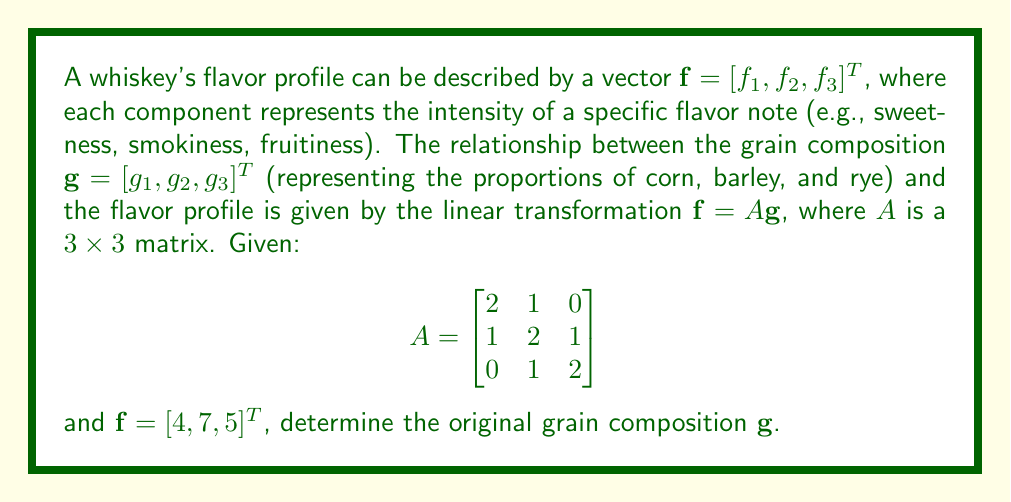Provide a solution to this math problem. To solve this inverse problem and determine the original grain composition, we need to find $\mathbf{g}$ given $\mathbf{f}$ and $A$. This involves solving the linear system $A\mathbf{g} = \mathbf{f}$.

Step 1: Set up the equation $A\mathbf{g} = \mathbf{f}$:
$$\begin{bmatrix}
2 & 1 & 0 \\
1 & 2 & 1 \\
0 & 1 & 2
\end{bmatrix} \begin{bmatrix}
g_1 \\
g_2 \\
g_3
\end{bmatrix} = \begin{bmatrix}
4 \\
7 \\
5
\end{bmatrix}$$

Step 2: To solve this system, we can use Gaussian elimination or matrix inversion. Let's use matrix inversion. We need to find $A^{-1}$.

Step 3: Calculate $A^{-1}$:
$$A^{-1} = \frac{1}{7}\begin{bmatrix}
3 & -1 & 0 \\
-1 & 3 & -1 \\
1 & -1 & 3
\end{bmatrix}$$

Step 4: Multiply both sides of the equation by $A^{-1}$:
$$\mathbf{g} = A^{-1}\mathbf{f}$$

Step 5: Perform the matrix multiplication:
$$\mathbf{g} = \frac{1}{7}\begin{bmatrix}
3 & -1 & 0 \\
-1 & 3 & -1 \\
1 & -1 & 3
\end{bmatrix} \begin{bmatrix}
4 \\
7 \\
5
\end{bmatrix}$$

Step 6: Calculate the result:
$$\mathbf{g} = \frac{1}{7}\begin{bmatrix}
3(4) + (-1)(7) + 0(5) \\
(-1)(4) + 3(7) + (-1)(5) \\
1(4) + (-1)(7) + 3(5)
\end{bmatrix} = \frac{1}{7}\begin{bmatrix}
5 \\
14 \\
12
\end{bmatrix} = \begin{bmatrix}
5/7 \\
2 \\
12/7
\end{bmatrix}$$
Answer: $\mathbf{g} = [5/7, 2, 12/7]^T$ 